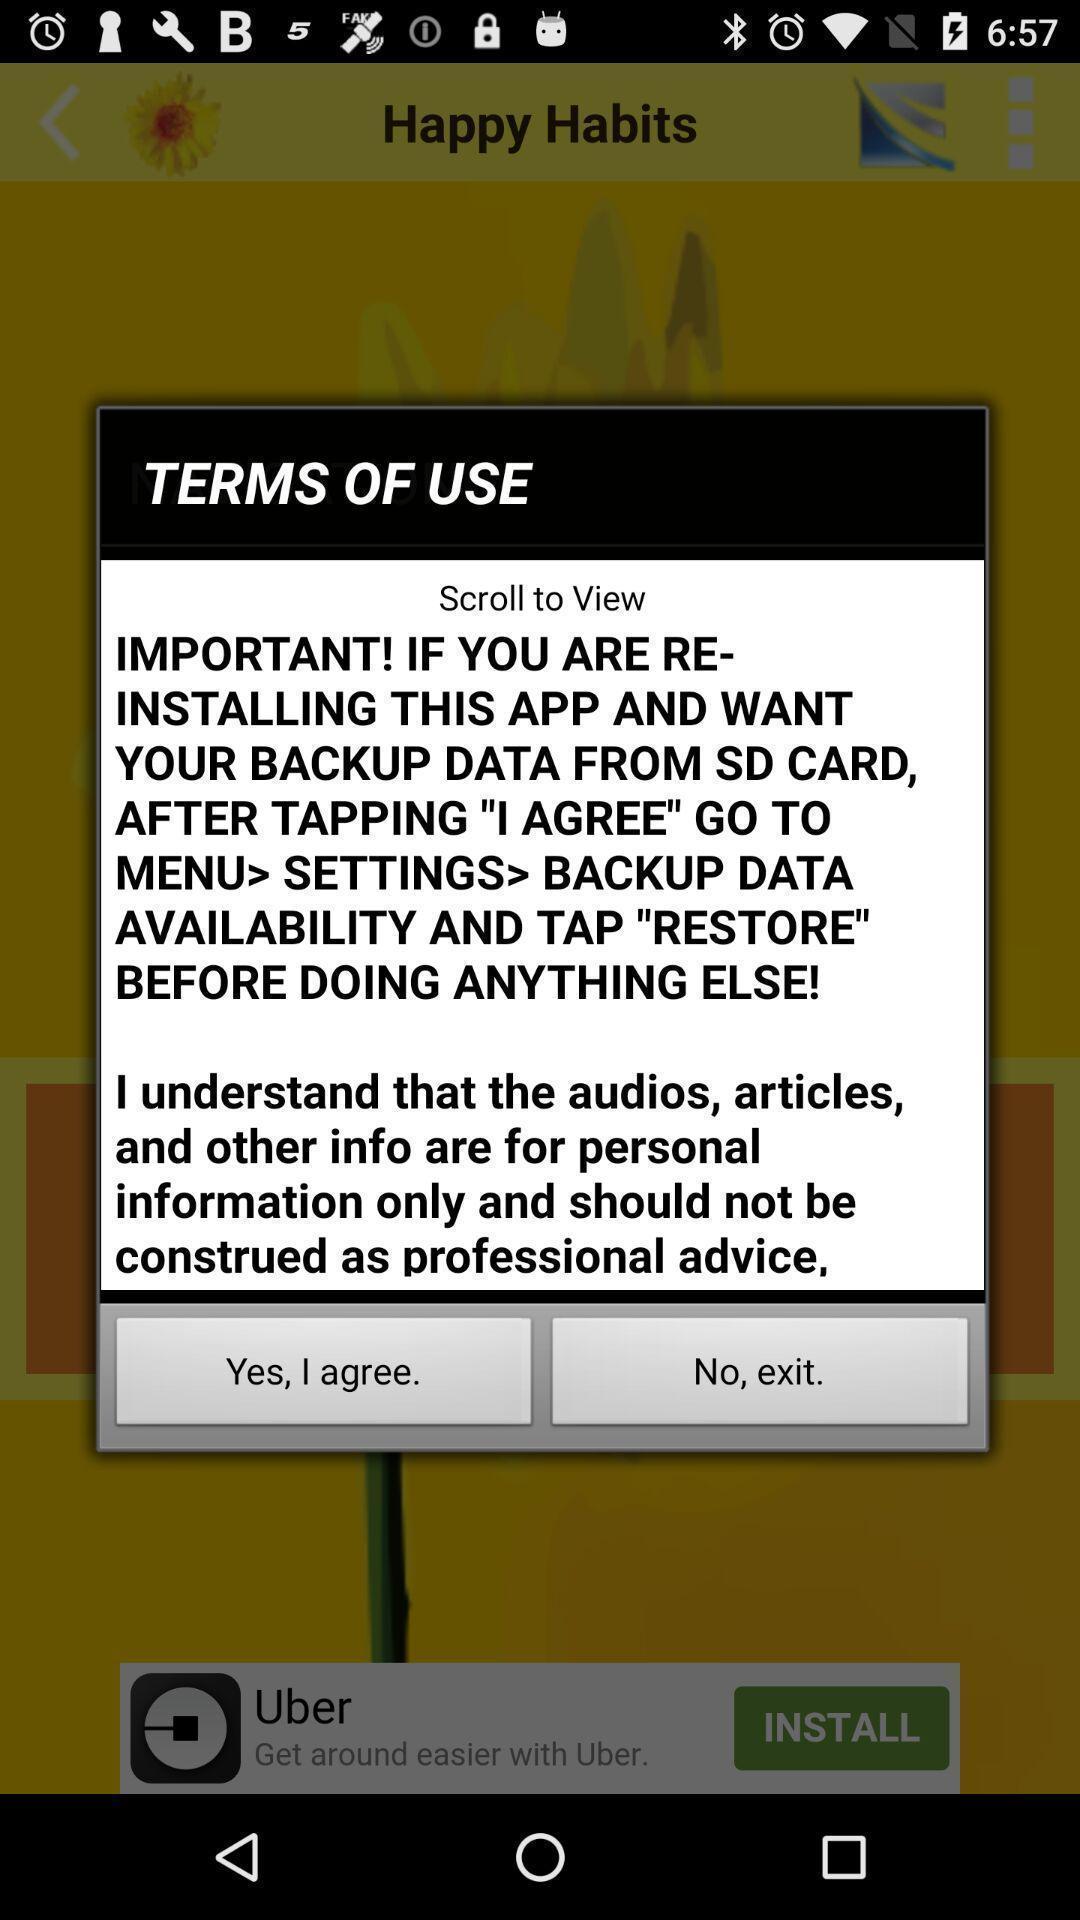Provide a detailed account of this screenshot. Pop-up shows terms of use. 